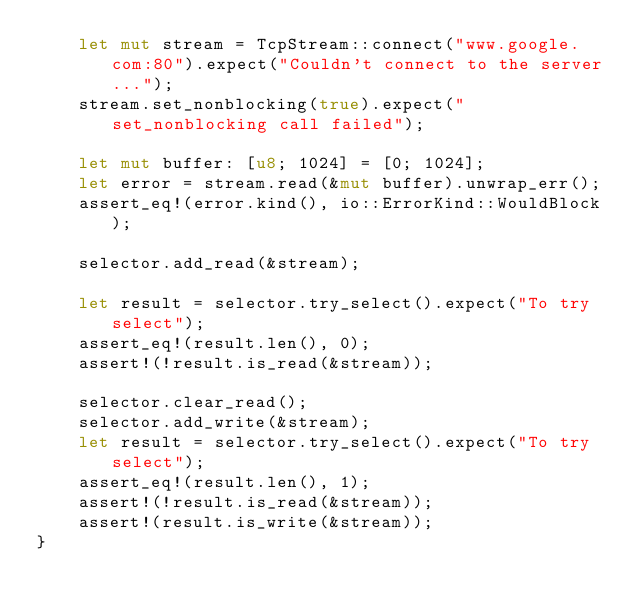Convert code to text. <code><loc_0><loc_0><loc_500><loc_500><_Rust_>    let mut stream = TcpStream::connect("www.google.com:80").expect("Couldn't connect to the server...");
    stream.set_nonblocking(true).expect("set_nonblocking call failed");

    let mut buffer: [u8; 1024] = [0; 1024];
    let error = stream.read(&mut buffer).unwrap_err();
    assert_eq!(error.kind(), io::ErrorKind::WouldBlock);

    selector.add_read(&stream);

    let result = selector.try_select().expect("To try select");
    assert_eq!(result.len(), 0);
    assert!(!result.is_read(&stream));

    selector.clear_read();
    selector.add_write(&stream);
    let result = selector.try_select().expect("To try select");
    assert_eq!(result.len(), 1);
    assert!(!result.is_read(&stream));
    assert!(result.is_write(&stream));
}
</code> 